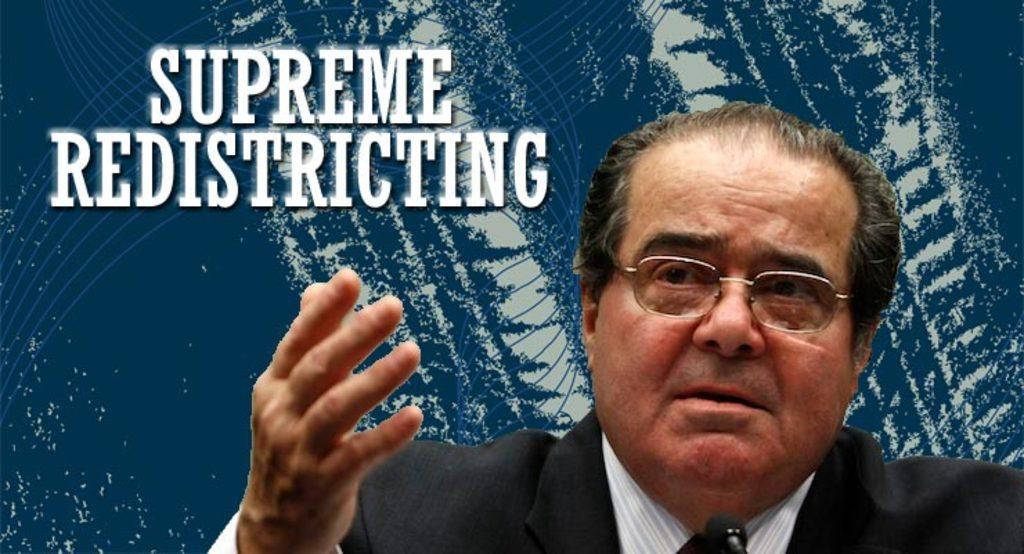What is the main subject of the picture? The main subject of the picture is a man. What can be observed about the man's appearance? The man is wearing spectacles and a suit. What is located beside the man in the image? There is an edited image beside the man. Can you describe any additional features of the image? There is a watermark in the top left corner of the image. What type of collar can be seen on the jellyfish in the image? There is no jellyfish present in the image; it features a man wearing spectacles and a suit, with an edited image and a watermark. 